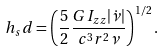<formula> <loc_0><loc_0><loc_500><loc_500>h _ { s } d = \left ( \frac { 5 } { 2 } \frac { G I _ { z z } | \dot { \nu } | } { c ^ { 3 } r ^ { 2 } \nu } \right ) ^ { 1 / 2 } .</formula> 